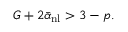<formula> <loc_0><loc_0><loc_500><loc_500>G + 2 \bar { \alpha } _ { n l } > 3 - p .</formula> 